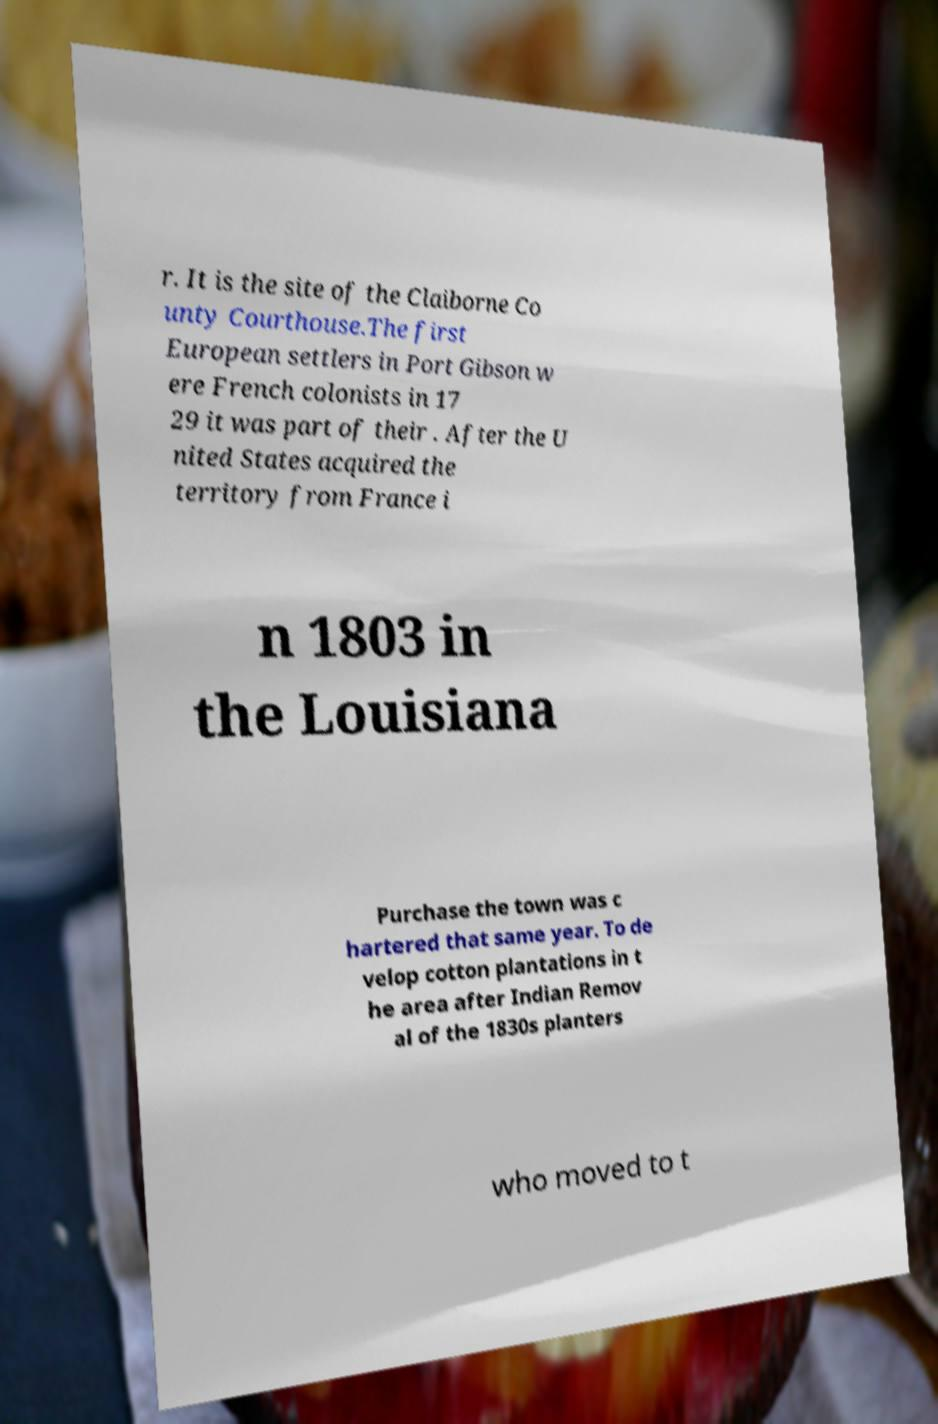Could you assist in decoding the text presented in this image and type it out clearly? r. It is the site of the Claiborne Co unty Courthouse.The first European settlers in Port Gibson w ere French colonists in 17 29 it was part of their . After the U nited States acquired the territory from France i n 1803 in the Louisiana Purchase the town was c hartered that same year. To de velop cotton plantations in t he area after Indian Remov al of the 1830s planters who moved to t 